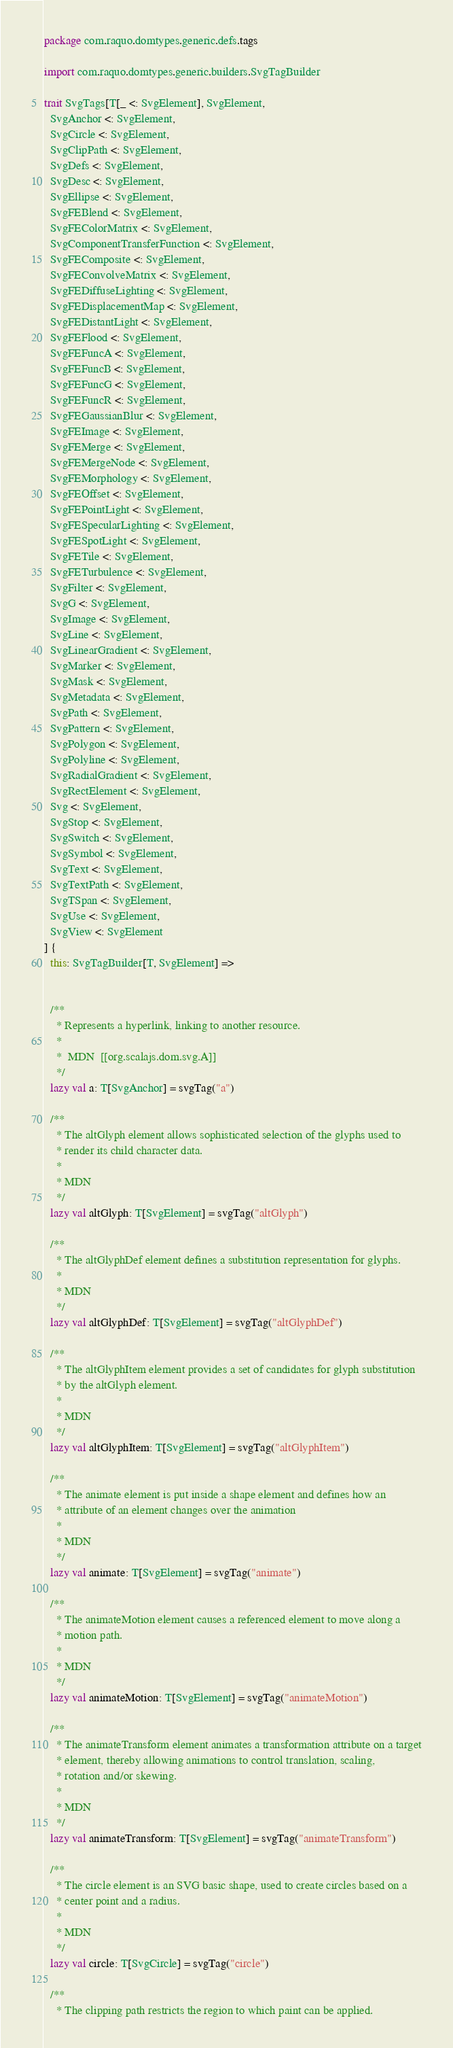<code> <loc_0><loc_0><loc_500><loc_500><_Scala_>package com.raquo.domtypes.generic.defs.tags

import com.raquo.domtypes.generic.builders.SvgTagBuilder

trait SvgTags[T[_ <: SvgElement], SvgElement,
  SvgAnchor <: SvgElement,
  SvgCircle <: SvgElement,
  SvgClipPath <: SvgElement,
  SvgDefs <: SvgElement,
  SvgDesc <: SvgElement,
  SvgEllipse <: SvgElement,
  SvgFEBlend <: SvgElement,
  SvgFEColorMatrix <: SvgElement,
  SvgComponentTransferFunction <: SvgElement,
  SvgFEComposite <: SvgElement,
  SvgFEConvolveMatrix <: SvgElement,
  SvgFEDiffuseLighting <: SvgElement,
  SvgFEDisplacementMap <: SvgElement,
  SvgFEDistantLight <: SvgElement,
  SvgFEFlood <: SvgElement,
  SvgFEFuncA <: SvgElement,
  SvgFEFuncB <: SvgElement,
  SvgFEFuncG <: SvgElement,
  SvgFEFuncR <: SvgElement,
  SvgFEGaussianBlur <: SvgElement,
  SvgFEImage <: SvgElement,
  SvgFEMerge <: SvgElement,
  SvgFEMergeNode <: SvgElement,
  SvgFEMorphology <: SvgElement,
  SvgFEOffset <: SvgElement,
  SvgFEPointLight <: SvgElement,
  SvgFESpecularLighting <: SvgElement,
  SvgFESpotLight <: SvgElement,
  SvgFETile <: SvgElement,
  SvgFETurbulence <: SvgElement,
  SvgFilter <: SvgElement,
  SvgG <: SvgElement,
  SvgImage <: SvgElement,
  SvgLine <: SvgElement,
  SvgLinearGradient <: SvgElement,
  SvgMarker <: SvgElement,
  SvgMask <: SvgElement,
  SvgMetadata <: SvgElement,
  SvgPath <: SvgElement,
  SvgPattern <: SvgElement,
  SvgPolygon <: SvgElement,
  SvgPolyline <: SvgElement,
  SvgRadialGradient <: SvgElement,
  SvgRectElement <: SvgElement,
  Svg <: SvgElement,
  SvgStop <: SvgElement,
  SvgSwitch <: SvgElement,
  SvgSymbol <: SvgElement,
  SvgText <: SvgElement,
  SvgTextPath <: SvgElement,
  SvgTSpan <: SvgElement,
  SvgUse <: SvgElement,
  SvgView <: SvgElement
] {
  this: SvgTagBuilder[T, SvgElement] =>


  /**
    * Represents a hyperlink, linking to another resource.
    *
    *  MDN  [[org.scalajs.dom.svg.A]]
    */
  lazy val a: T[SvgAnchor] = svgTag("a")

  /**
    * The altGlyph element allows sophisticated selection of the glyphs used to
    * render its child character data.
    *
    * MDN
    */
  lazy val altGlyph: T[SvgElement] = svgTag("altGlyph")

  /**
    * The altGlyphDef element defines a substitution representation for glyphs.
    *
    * MDN
    */
  lazy val altGlyphDef: T[SvgElement] = svgTag("altGlyphDef")

  /**
    * The altGlyphItem element provides a set of candidates for glyph substitution
    * by the altGlyph element.
    *
    * MDN
    */
  lazy val altGlyphItem: T[SvgElement] = svgTag("altGlyphItem")

  /**
    * The animate element is put inside a shape element and defines how an
    * attribute of an element changes over the animation
    *
    * MDN
    */
  lazy val animate: T[SvgElement] = svgTag("animate")

  /**
    * The animateMotion element causes a referenced element to move along a
    * motion path.
    *
    * MDN
    */
  lazy val animateMotion: T[SvgElement] = svgTag("animateMotion")

  /**
    * The animateTransform element animates a transformation attribute on a target
    * element, thereby allowing animations to control translation, scaling,
    * rotation and/or skewing.
    *
    * MDN
    */
  lazy val animateTransform: T[SvgElement] = svgTag("animateTransform")

  /**
    * The circle element is an SVG basic shape, used to create circles based on a
    * center point and a radius.
    *
    * MDN
    */
  lazy val circle: T[SvgCircle] = svgTag("circle")

  /**
    * The clipping path restricts the region to which paint can be applied.</code> 